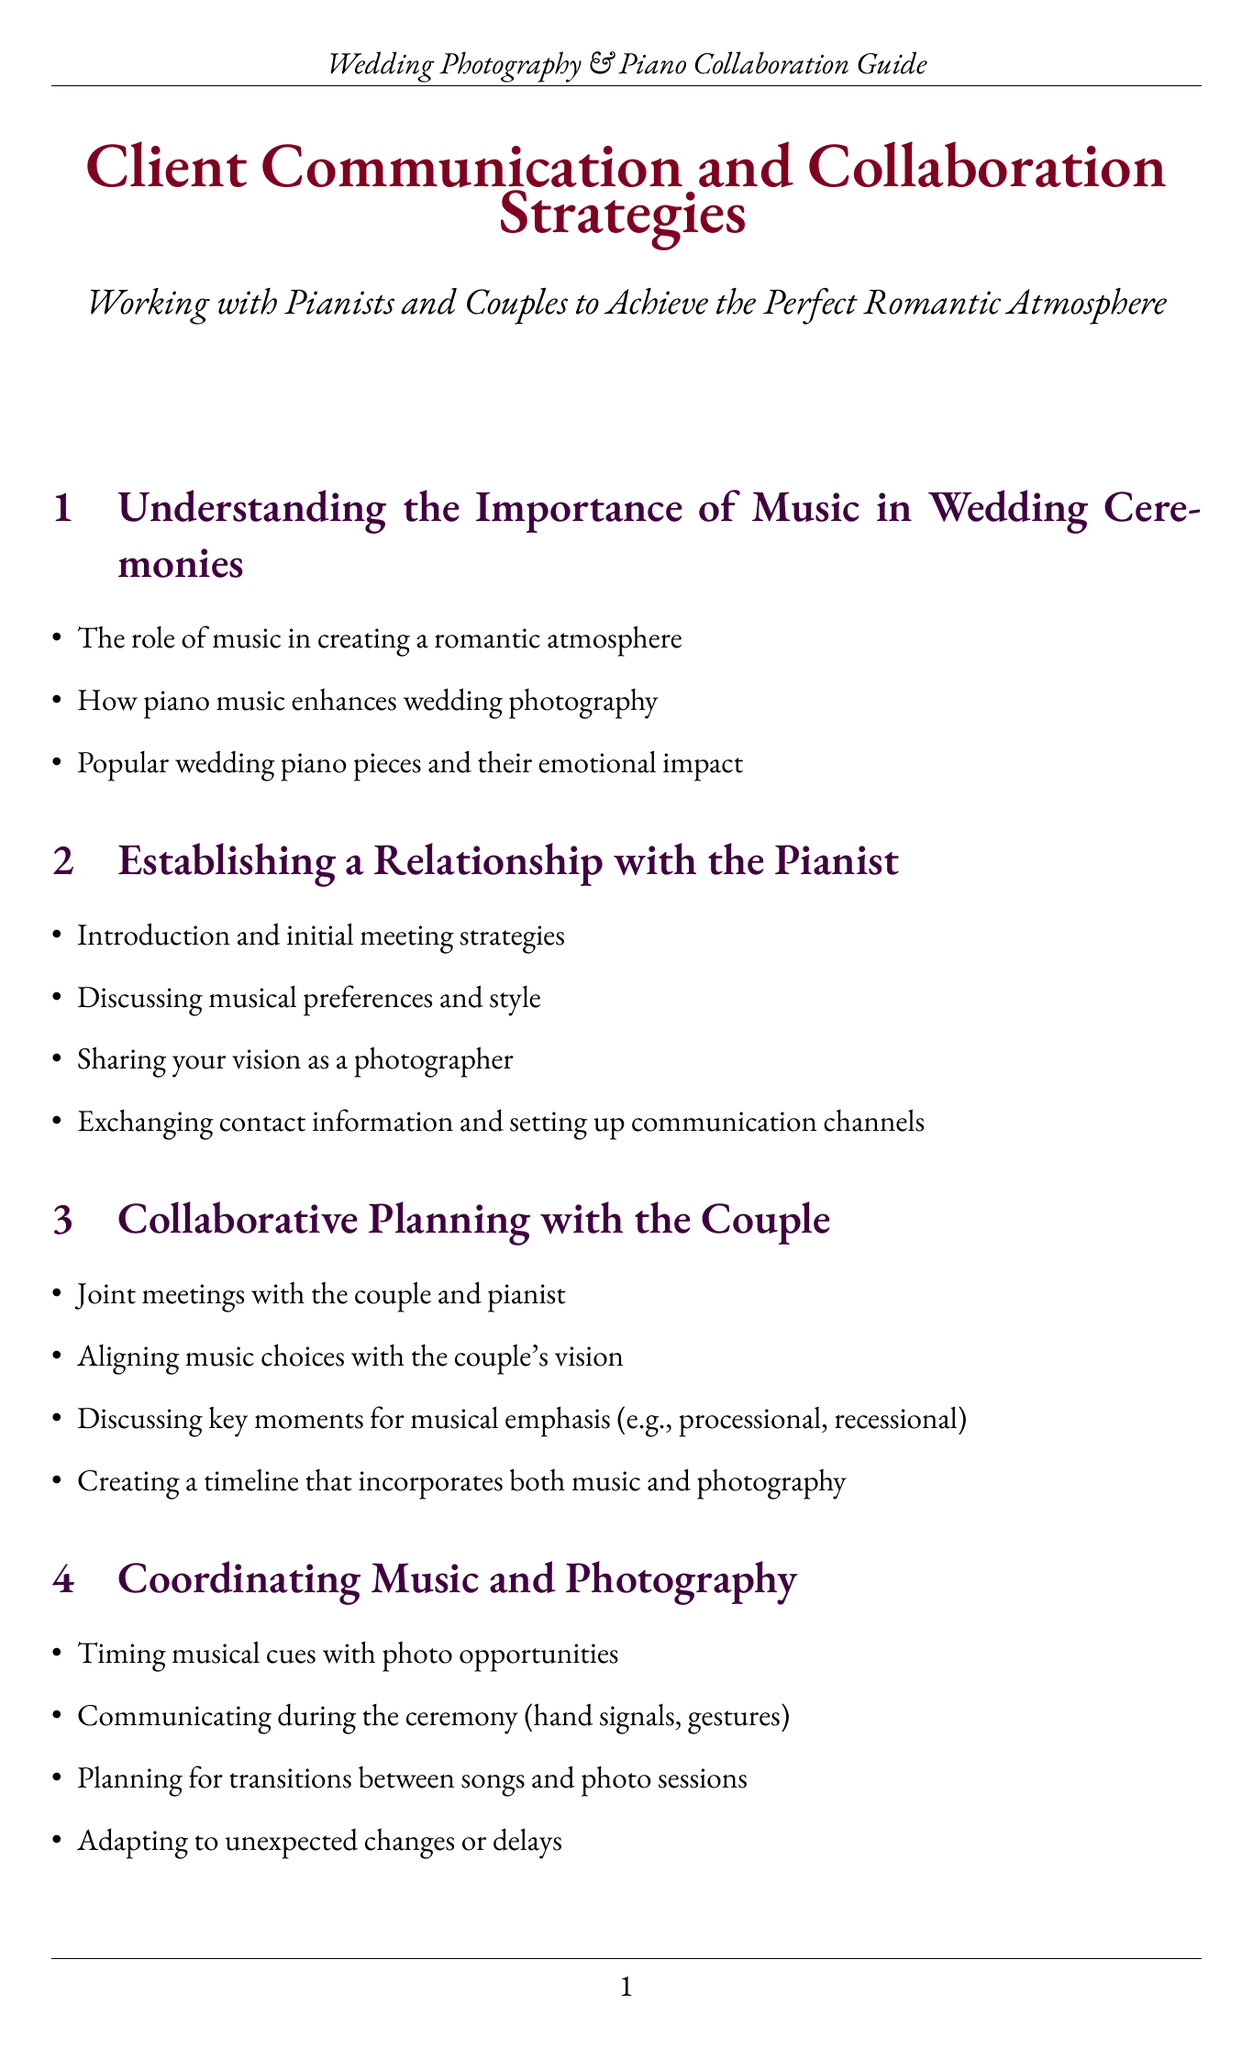What is the title of the manual? The title is presented at the beginning of the document and encapsulates the main focus of the guide.
Answer: Client Communication and Collaboration Strategies What is one example of a romantic piano piece mentioned? The manual lists specific piano pieces that evoke a romantic atmosphere, providing guidance for pianists.
Answer: Clair de Lune by Debussy What should be discussed during initial meetings with the pianist? This aspect addresses key points to establish a constructive relationship and ensure musical alignment for the ceremony.
Answer: Musical preferences and style What is the purpose of joint meetings with the couple and pianist? The document outlines the collaborative process to ensure all parties are aligned on music and photography for the wedding.
Answer: Aligning music choices with the couple's vision What is a key factor when coordinating music and photography? Understanding the interplay between musical selection and photography timing is essential for a successful wedding ceremony.
Answer: Timing musical cues with photo opportunities How can unexpected changes during a ceremony be managed? This section provides strategies for adapting to alterations that could impact the flow of music and photography.
Answer: Developing backup plans for musician absences or equipment failures What is a primary focus during the pre-wedding rehearsal? The manual emphasizes preparation for the ceremony as a critical time for final adjustments.
Answer: Finalizing the music and photography schedule What is the goal of post-wedding follow-up? This part highlights the importance of evaluating the collaboration after the event to foster future relationships.
Answer: Sharing successful moments and areas for improvement 